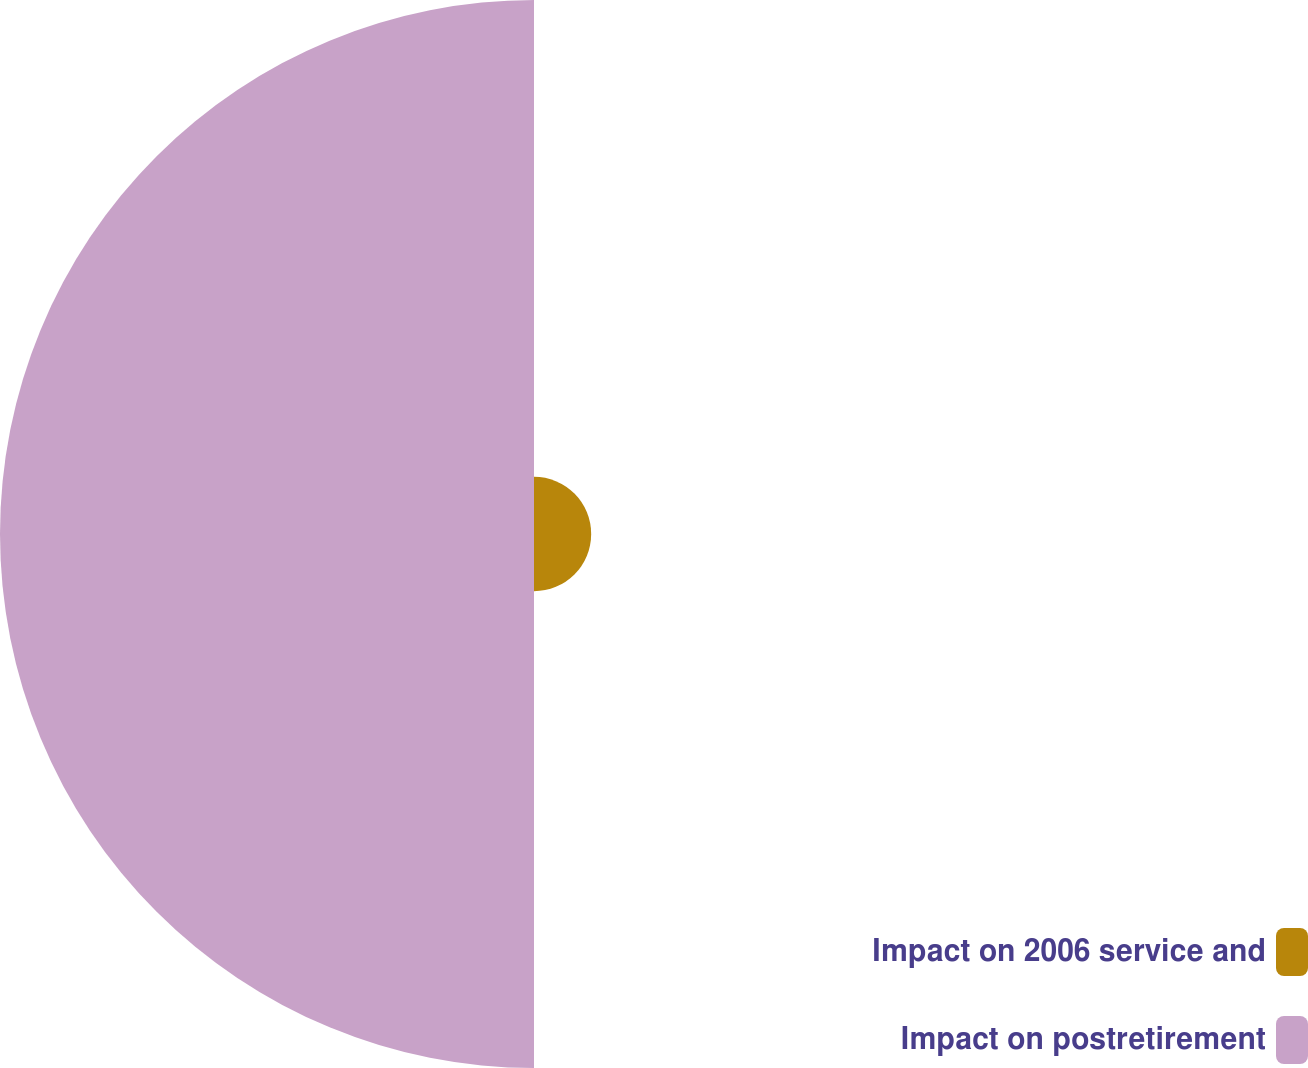Convert chart to OTSL. <chart><loc_0><loc_0><loc_500><loc_500><pie_chart><fcel>Impact on 2006 service and<fcel>Impact on postretirement<nl><fcel>9.67%<fcel>90.33%<nl></chart> 